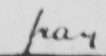Can you tell me what this handwritten text says? pay 